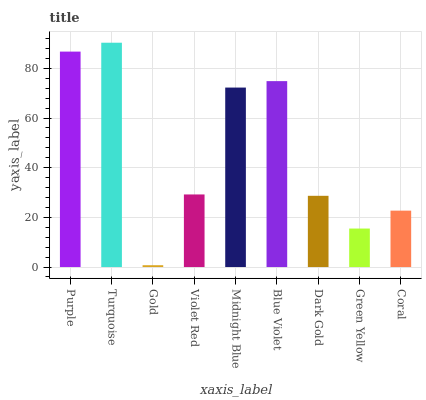Is Gold the minimum?
Answer yes or no. Yes. Is Turquoise the maximum?
Answer yes or no. Yes. Is Turquoise the minimum?
Answer yes or no. No. Is Gold the maximum?
Answer yes or no. No. Is Turquoise greater than Gold?
Answer yes or no. Yes. Is Gold less than Turquoise?
Answer yes or no. Yes. Is Gold greater than Turquoise?
Answer yes or no. No. Is Turquoise less than Gold?
Answer yes or no. No. Is Violet Red the high median?
Answer yes or no. Yes. Is Violet Red the low median?
Answer yes or no. Yes. Is Turquoise the high median?
Answer yes or no. No. Is Green Yellow the low median?
Answer yes or no. No. 